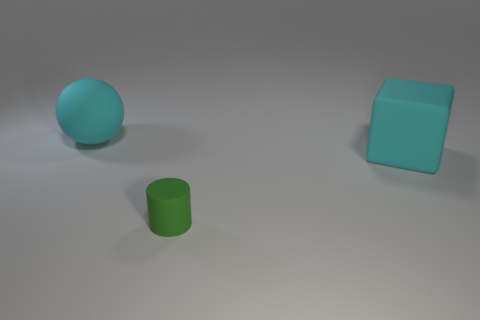Is there anything else that has the same shape as the small matte object?
Make the answer very short. No. Is there any other thing that is the same size as the rubber cylinder?
Provide a short and direct response. No. What color is the thing in front of the big cyan rubber object on the right side of the cyan matte thing that is left of the small green thing?
Your answer should be compact. Green. Are there the same number of large rubber cubes that are behind the green cylinder and tiny green objects?
Your answer should be very brief. Yes. There is a cyan thing on the left side of the cyan cube; is it the same size as the tiny green cylinder?
Give a very brief answer. No. What number of large cyan matte things are there?
Provide a succinct answer. 2. What number of large matte things are left of the cylinder and on the right side of the rubber sphere?
Your response must be concise. 0. Is there another small ball made of the same material as the cyan sphere?
Your response must be concise. No. The big cyan object on the right side of the large matte object that is to the left of the big matte block is made of what material?
Offer a terse response. Rubber. Is the number of spheres that are right of the large cyan sphere the same as the number of cyan matte objects to the left of the small green cylinder?
Your answer should be very brief. No. 